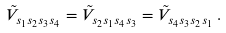<formula> <loc_0><loc_0><loc_500><loc_500>\tilde { V } _ { s _ { 1 } s _ { 2 } s _ { 3 } s _ { 4 } } = \tilde { V } _ { s _ { 2 } s _ { 1 } s _ { 4 } s _ { 3 } } = \tilde { V } _ { s _ { 4 } s _ { 3 } s _ { 2 } s _ { 1 } } \, .</formula> 